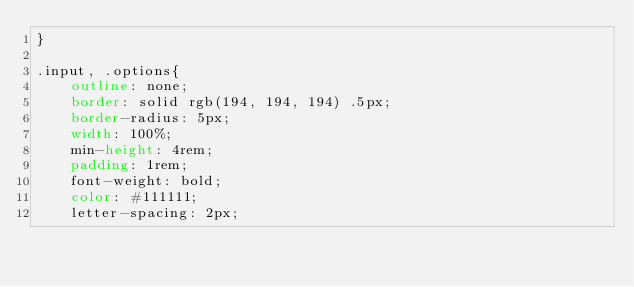Convert code to text. <code><loc_0><loc_0><loc_500><loc_500><_CSS_>}

.input, .options{
    outline: none;
    border: solid rgb(194, 194, 194) .5px;
    border-radius: 5px;
    width: 100%;
    min-height: 4rem;
    padding: 1rem;
    font-weight: bold;
    color: #111111;
    letter-spacing: 2px;</code> 